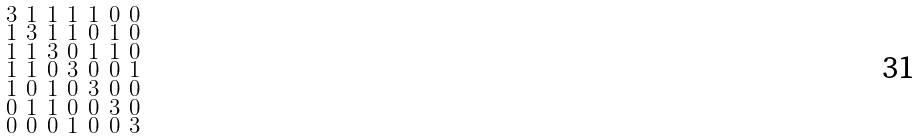Convert formula to latex. <formula><loc_0><loc_0><loc_500><loc_500>\begin{smallmatrix} 3 & 1 & 1 & 1 & 1 & 0 & 0 \\ 1 & 3 & 1 & 1 & 0 & 1 & 0 \\ 1 & 1 & 3 & 0 & 1 & 1 & 0 \\ 1 & 1 & 0 & 3 & 0 & 0 & 1 \\ 1 & 0 & 1 & 0 & 3 & 0 & 0 \\ 0 & 1 & 1 & 0 & 0 & 3 & 0 \\ 0 & 0 & 0 & 1 & 0 & 0 & 3 \end{smallmatrix}</formula> 